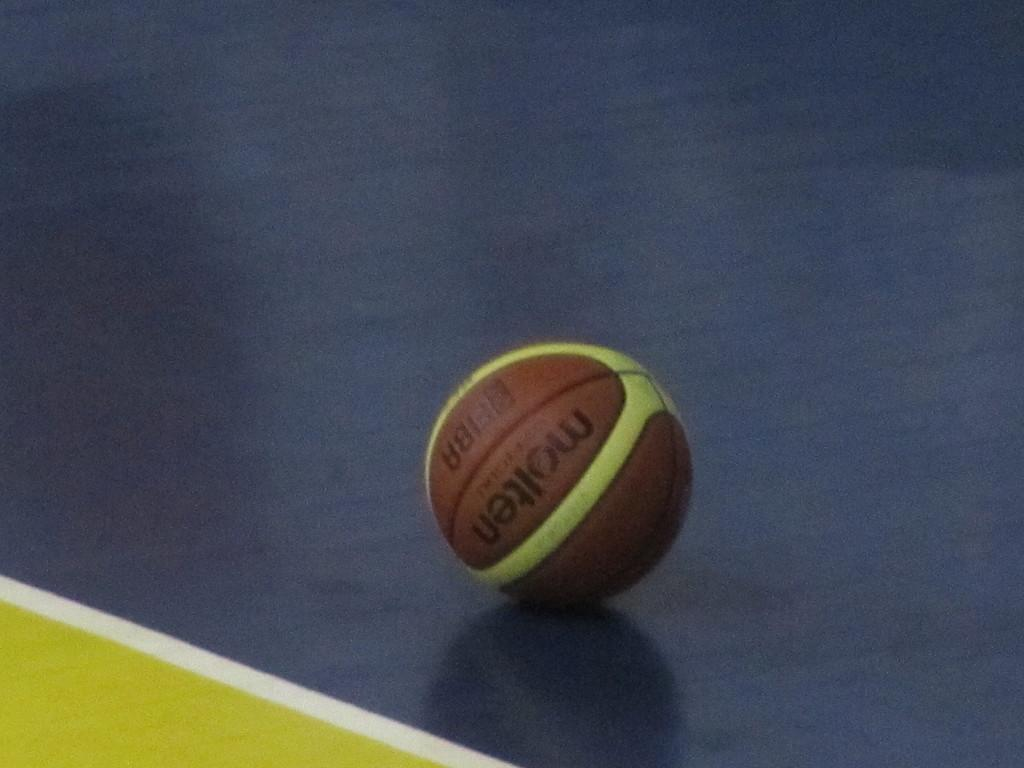What object is on the floor in the image? There is a ball on the floor in the image. Can you describe the appearance of the ball? The ball has brown and green colors. What colors are present on the floor in the image? The floor has blue and green colors. How many threads are visible on the ball in the image? There are no threads visible on the ball in the image. What type of berry can be seen growing on the floor in the image? There are no berries present in the image; it features a ball on the floor with blue and green colors. 